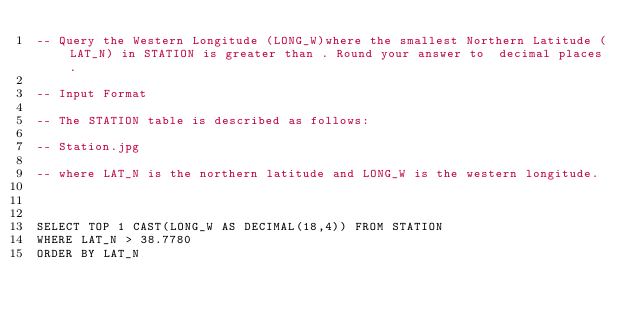Convert code to text. <code><loc_0><loc_0><loc_500><loc_500><_SQL_>-- Query the Western Longitude (LONG_W)where the smallest Northern Latitude (LAT_N) in STATION is greater than . Round your answer to  decimal places.

-- Input Format

-- The STATION table is described as follows:

-- Station.jpg

-- where LAT_N is the northern latitude and LONG_W is the western longitude.



SELECT TOP 1 CAST(LONG_W AS DECIMAL(18,4)) FROM STATION
WHERE LAT_N > 38.7780
ORDER BY LAT_N</code> 